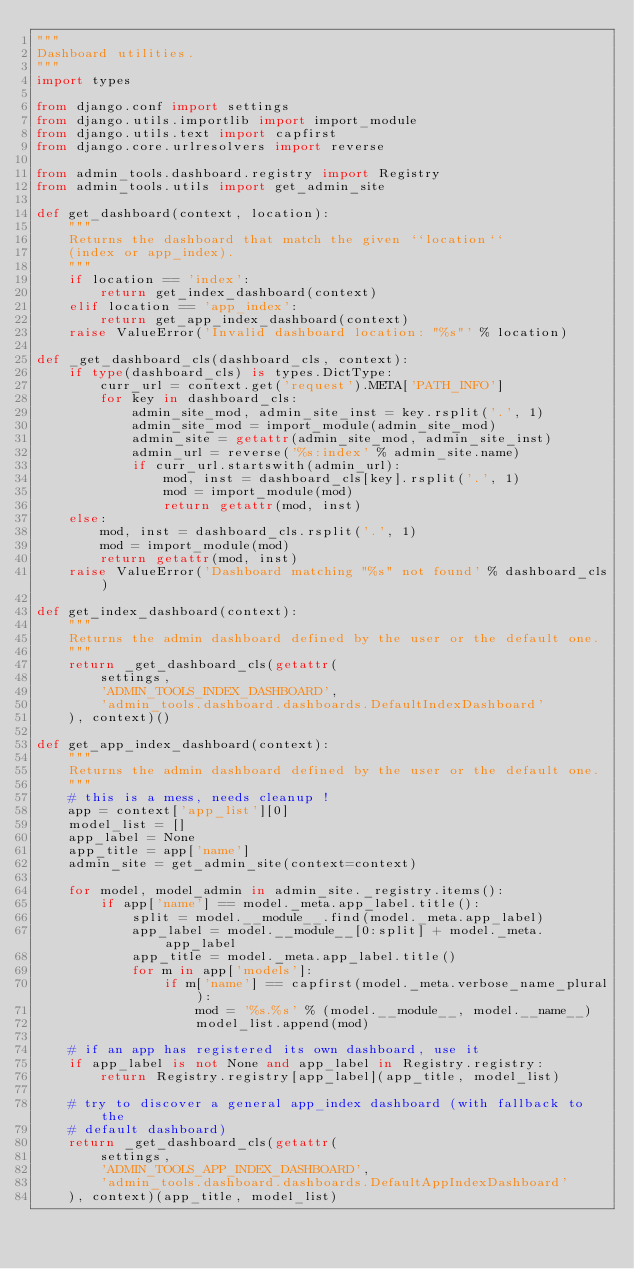Convert code to text. <code><loc_0><loc_0><loc_500><loc_500><_Python_>"""
Dashboard utilities.
"""
import types

from django.conf import settings
from django.utils.importlib import import_module
from django.utils.text import capfirst
from django.core.urlresolvers import reverse

from admin_tools.dashboard.registry import Registry
from admin_tools.utils import get_admin_site

def get_dashboard(context, location):
    """
    Returns the dashboard that match the given ``location``
    (index or app_index).
    """
    if location == 'index':
        return get_index_dashboard(context)
    elif location == 'app_index':
        return get_app_index_dashboard(context)
    raise ValueError('Invalid dashboard location: "%s"' % location)

def _get_dashboard_cls(dashboard_cls, context):
    if type(dashboard_cls) is types.DictType:
        curr_url = context.get('request').META['PATH_INFO']
        for key in dashboard_cls:
            admin_site_mod, admin_site_inst = key.rsplit('.', 1)
            admin_site_mod = import_module(admin_site_mod)
            admin_site = getattr(admin_site_mod, admin_site_inst)
            admin_url = reverse('%s:index' % admin_site.name)
            if curr_url.startswith(admin_url):
                mod, inst = dashboard_cls[key].rsplit('.', 1)
                mod = import_module(mod)
                return getattr(mod, inst)
    else:
        mod, inst = dashboard_cls.rsplit('.', 1)
        mod = import_module(mod)
        return getattr(mod, inst)
    raise ValueError('Dashboard matching "%s" not found' % dashboard_cls)

def get_index_dashboard(context):
    """
    Returns the admin dashboard defined by the user or the default one.
    """
    return _get_dashboard_cls(getattr(
        settings,
        'ADMIN_TOOLS_INDEX_DASHBOARD',
        'admin_tools.dashboard.dashboards.DefaultIndexDashboard'
    ), context)()

def get_app_index_dashboard(context):
    """
    Returns the admin dashboard defined by the user or the default one.
    """
    # this is a mess, needs cleanup !
    app = context['app_list'][0]
    model_list = []
    app_label = None
    app_title = app['name']
    admin_site = get_admin_site(context=context)

    for model, model_admin in admin_site._registry.items():
        if app['name'] == model._meta.app_label.title():
            split = model.__module__.find(model._meta.app_label)
            app_label = model.__module__[0:split] + model._meta.app_label
            app_title = model._meta.app_label.title()
            for m in app['models']:
                if m['name'] == capfirst(model._meta.verbose_name_plural):
                    mod = '%s.%s' % (model.__module__, model.__name__)
                    model_list.append(mod)

    # if an app has registered its own dashboard, use it
    if app_label is not None and app_label in Registry.registry:
        return Registry.registry[app_label](app_title, model_list)

    # try to discover a general app_index dashboard (with fallback to the
    # default dashboard)
    return _get_dashboard_cls(getattr(
        settings,
        'ADMIN_TOOLS_APP_INDEX_DASHBOARD',
        'admin_tools.dashboard.dashboards.DefaultAppIndexDashboard'
    ), context)(app_title, model_list)
</code> 